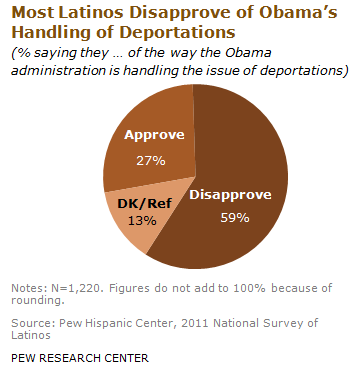Draw attention to some important aspects in this diagram. The smallest percentage of DK/Ref voters who disapprove is 46%, and this percentage difference is the first piece of information we have on how voters feel about the upcoming EU election. The DK/Ref is the smallest percentage value that can be achieved when comparing two values. For example, if a player has a DK of 13 and a Ref of 15, the DK/Ref is 13/15 or 0.867, which is the smallest percentage value that can be achieved for this comparison. 